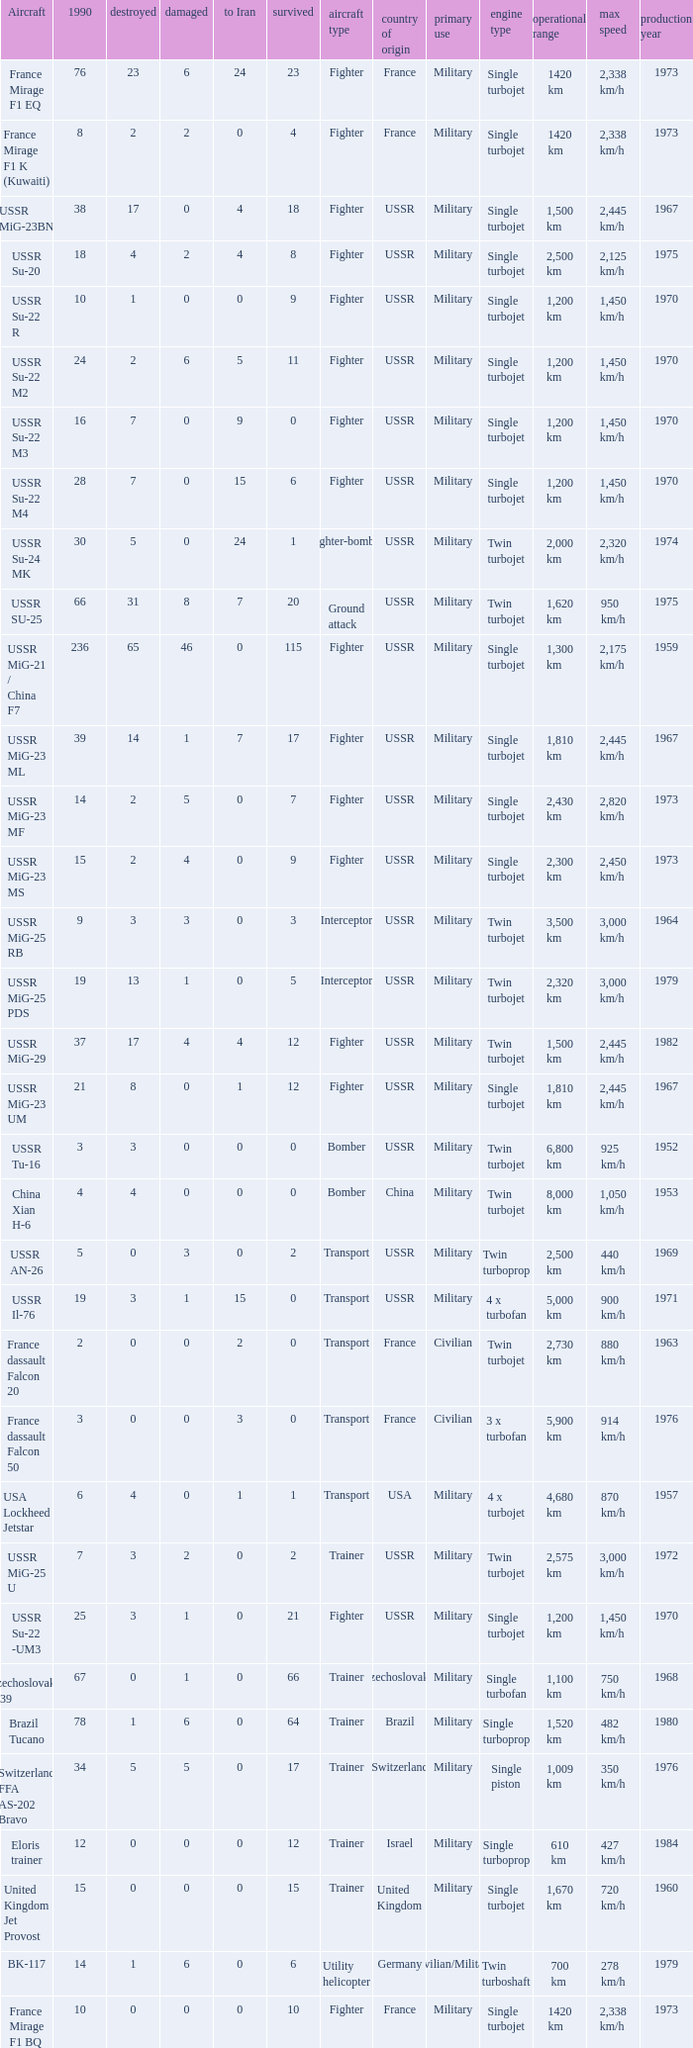If there were 14 in 1990 and 6 survived how many were destroyed? 1.0. 